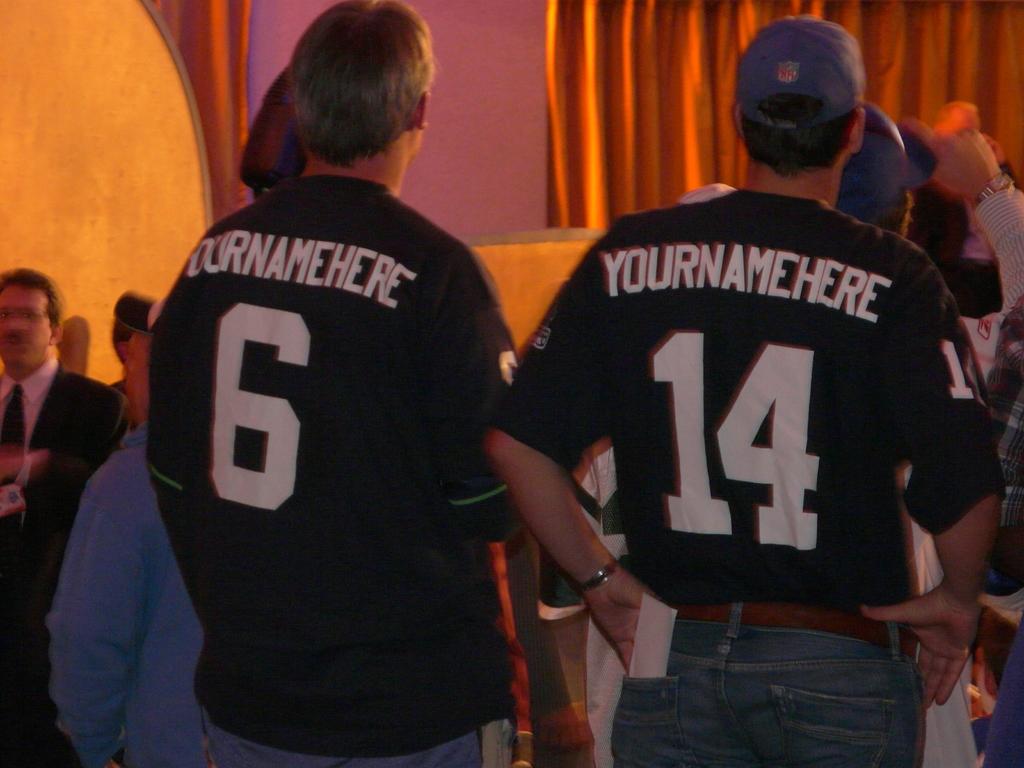What is the name on the back of the jerseys?
Provide a succinct answer. Yournamehere. What numbers are on the back of the jerseys?
Provide a succinct answer. 6 14. 